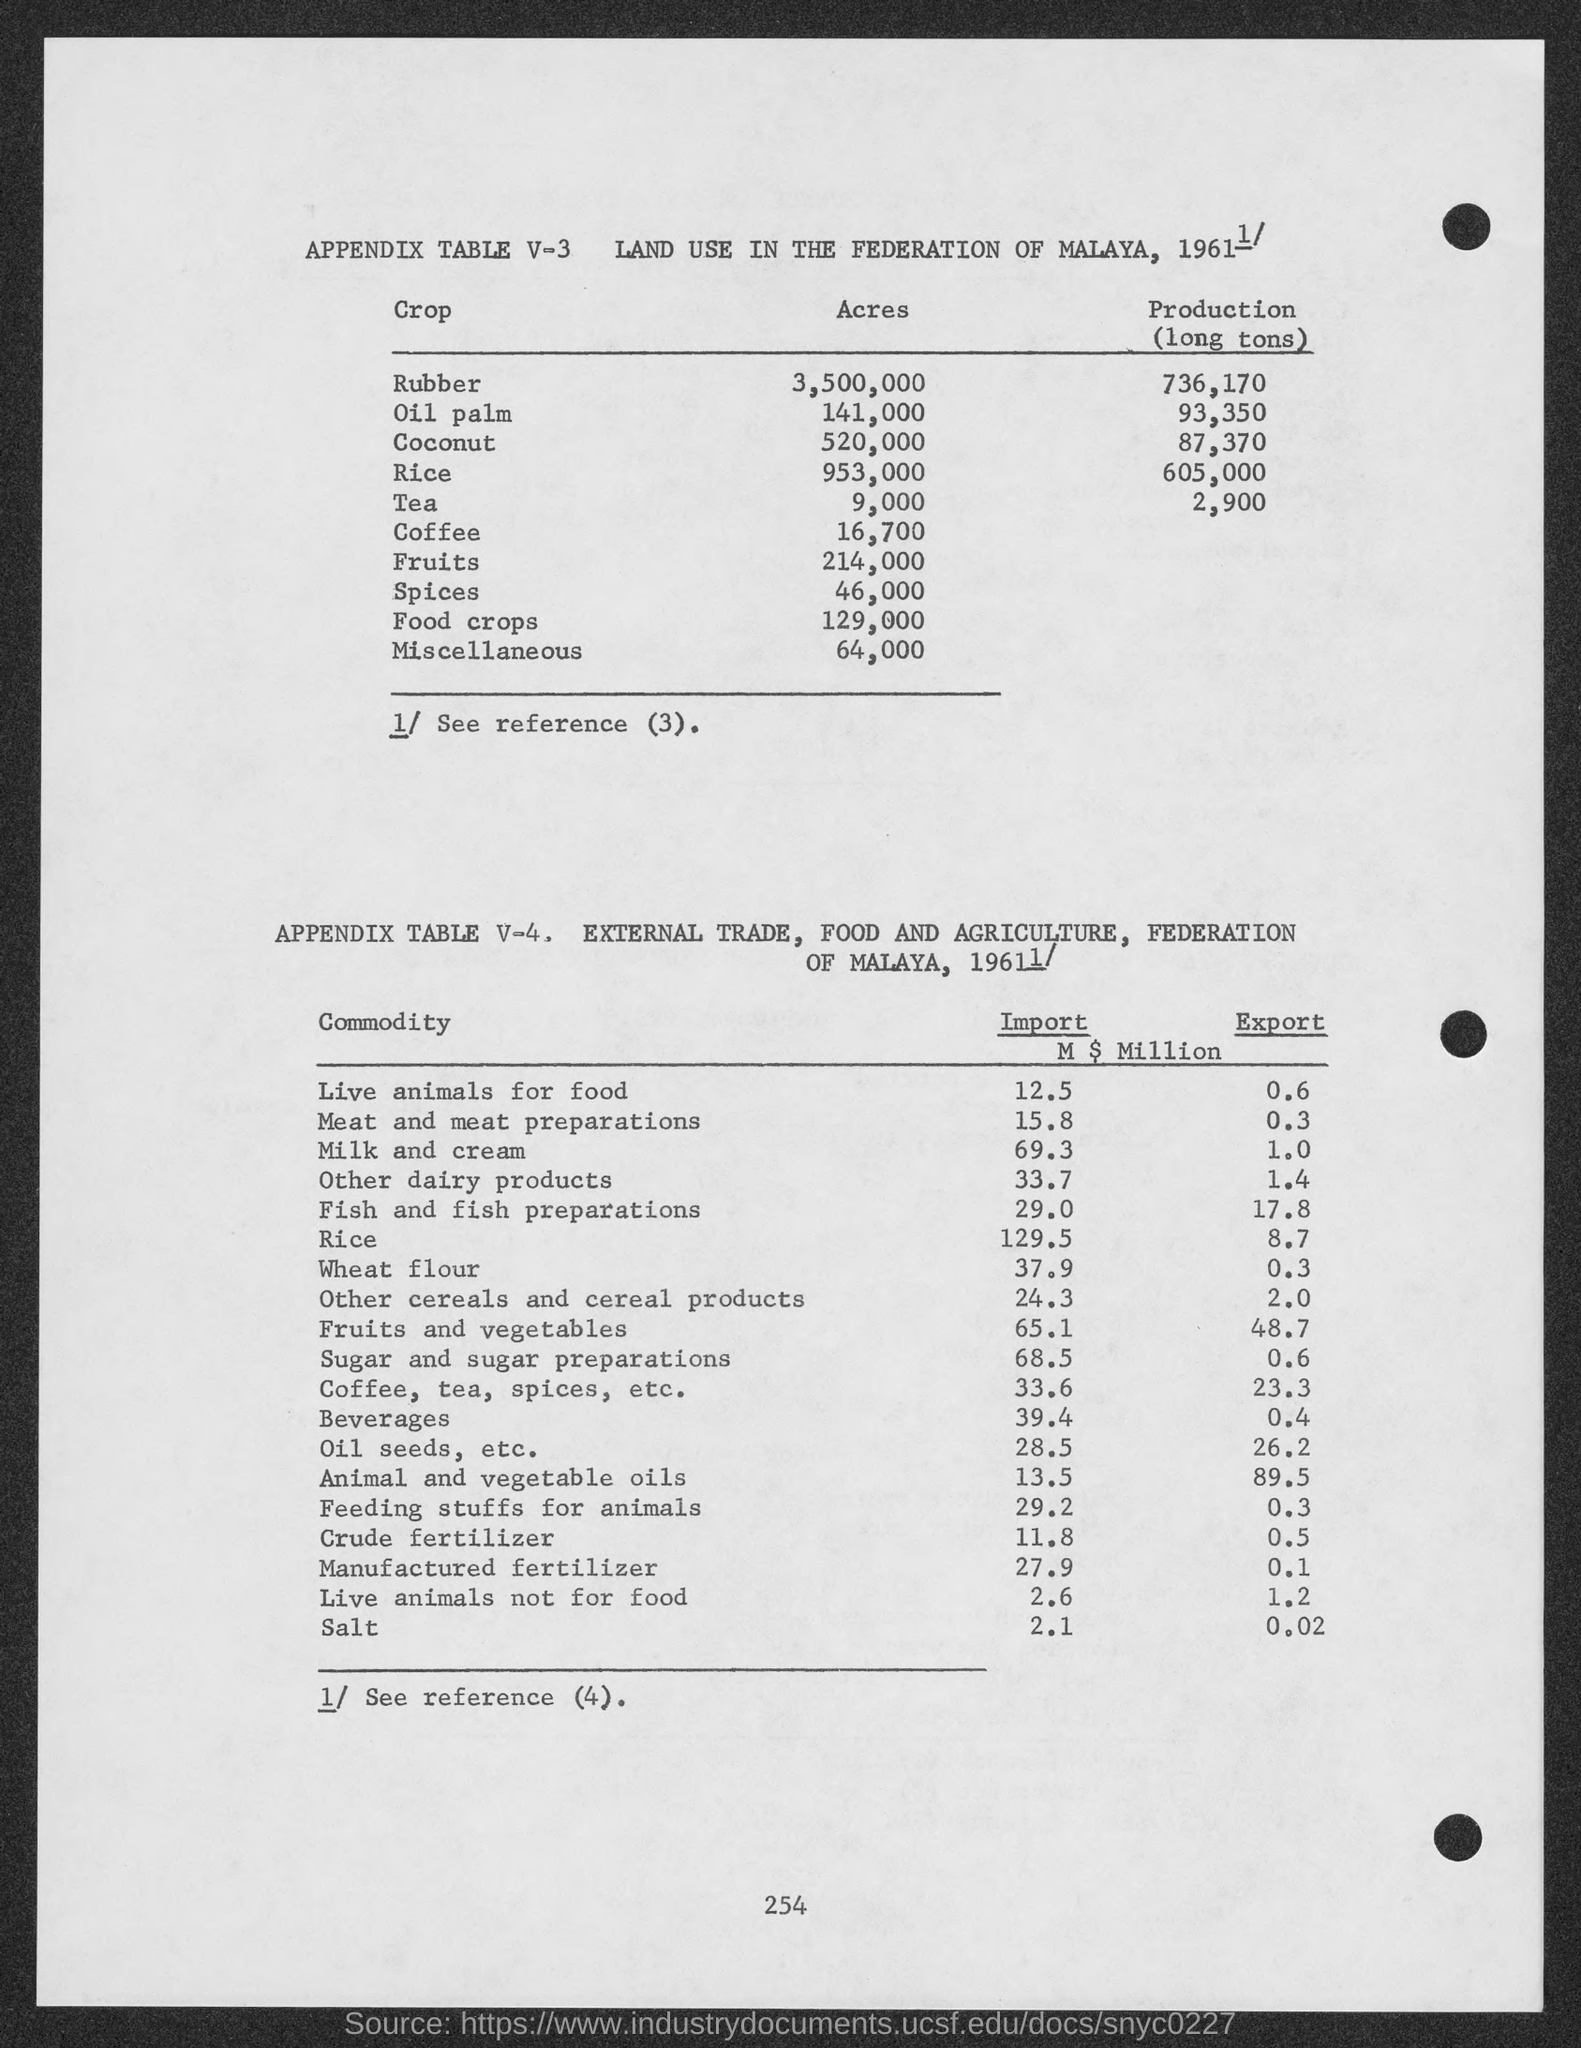Outline some significant characteristics in this image. I have 16,700 acres of coffee. Approximately 520,000 acres of coconut trees exist. Approximately 953,000 acres of rice were harvested. There are approximately 3,500,000 acres of rubber. The area of oil palm plantations totaled 141,000 acres. 